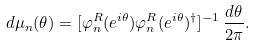Convert formula to latex. <formula><loc_0><loc_0><loc_500><loc_500>d \mu _ { n } ( \theta ) = [ \varphi _ { n } ^ { R } ( e ^ { i \theta } ) \varphi _ { n } ^ { R } ( e ^ { i \theta } ) ^ { \dagger } ] ^ { - 1 } \, \frac { d \theta } { 2 \pi } .</formula> 